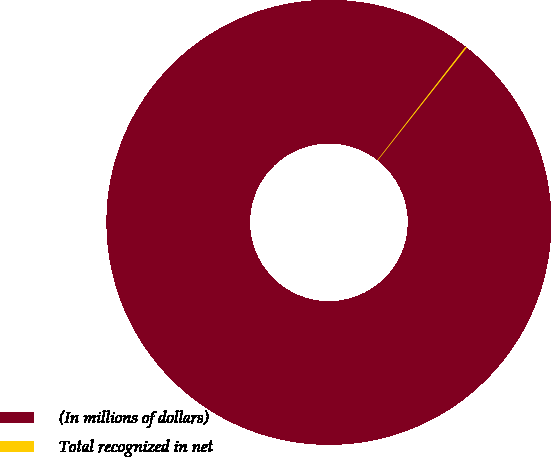Convert chart to OTSL. <chart><loc_0><loc_0><loc_500><loc_500><pie_chart><fcel>(In millions of dollars)<fcel>Total recognized in net<nl><fcel>99.9%<fcel>0.1%<nl></chart> 